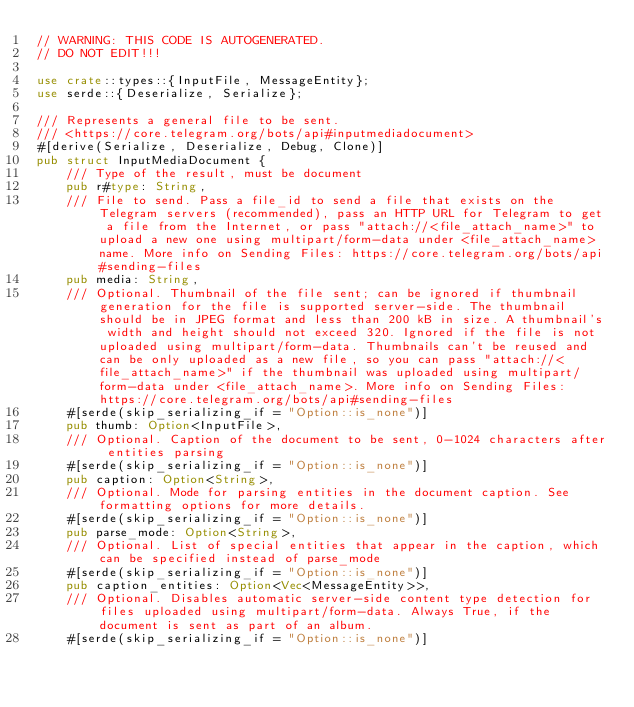Convert code to text. <code><loc_0><loc_0><loc_500><loc_500><_Rust_>// WARNING: THIS CODE IS AUTOGENERATED.
// DO NOT EDIT!!!

use crate::types::{InputFile, MessageEntity};
use serde::{Deserialize, Serialize};

/// Represents a general file to be sent.
/// <https://core.telegram.org/bots/api#inputmediadocument>
#[derive(Serialize, Deserialize, Debug, Clone)]
pub struct InputMediaDocument {
    /// Type of the result, must be document
    pub r#type: String,
    /// File to send. Pass a file_id to send a file that exists on the Telegram servers (recommended), pass an HTTP URL for Telegram to get a file from the Internet, or pass "attach://<file_attach_name>" to upload a new one using multipart/form-data under <file_attach_name> name. More info on Sending Files: https://core.telegram.org/bots/api#sending-files
    pub media: String,
    /// Optional. Thumbnail of the file sent; can be ignored if thumbnail generation for the file is supported server-side. The thumbnail should be in JPEG format and less than 200 kB in size. A thumbnail's width and height should not exceed 320. Ignored if the file is not uploaded using multipart/form-data. Thumbnails can't be reused and can be only uploaded as a new file, so you can pass "attach://<file_attach_name>" if the thumbnail was uploaded using multipart/form-data under <file_attach_name>. More info on Sending Files: https://core.telegram.org/bots/api#sending-files
    #[serde(skip_serializing_if = "Option::is_none")]
    pub thumb: Option<InputFile>,
    /// Optional. Caption of the document to be sent, 0-1024 characters after entities parsing
    #[serde(skip_serializing_if = "Option::is_none")]
    pub caption: Option<String>,
    /// Optional. Mode for parsing entities in the document caption. See formatting options for more details.
    #[serde(skip_serializing_if = "Option::is_none")]
    pub parse_mode: Option<String>,
    /// Optional. List of special entities that appear in the caption, which can be specified instead of parse_mode
    #[serde(skip_serializing_if = "Option::is_none")]
    pub caption_entities: Option<Vec<MessageEntity>>,
    /// Optional. Disables automatic server-side content type detection for files uploaded using multipart/form-data. Always True, if the document is sent as part of an album.
    #[serde(skip_serializing_if = "Option::is_none")]</code> 